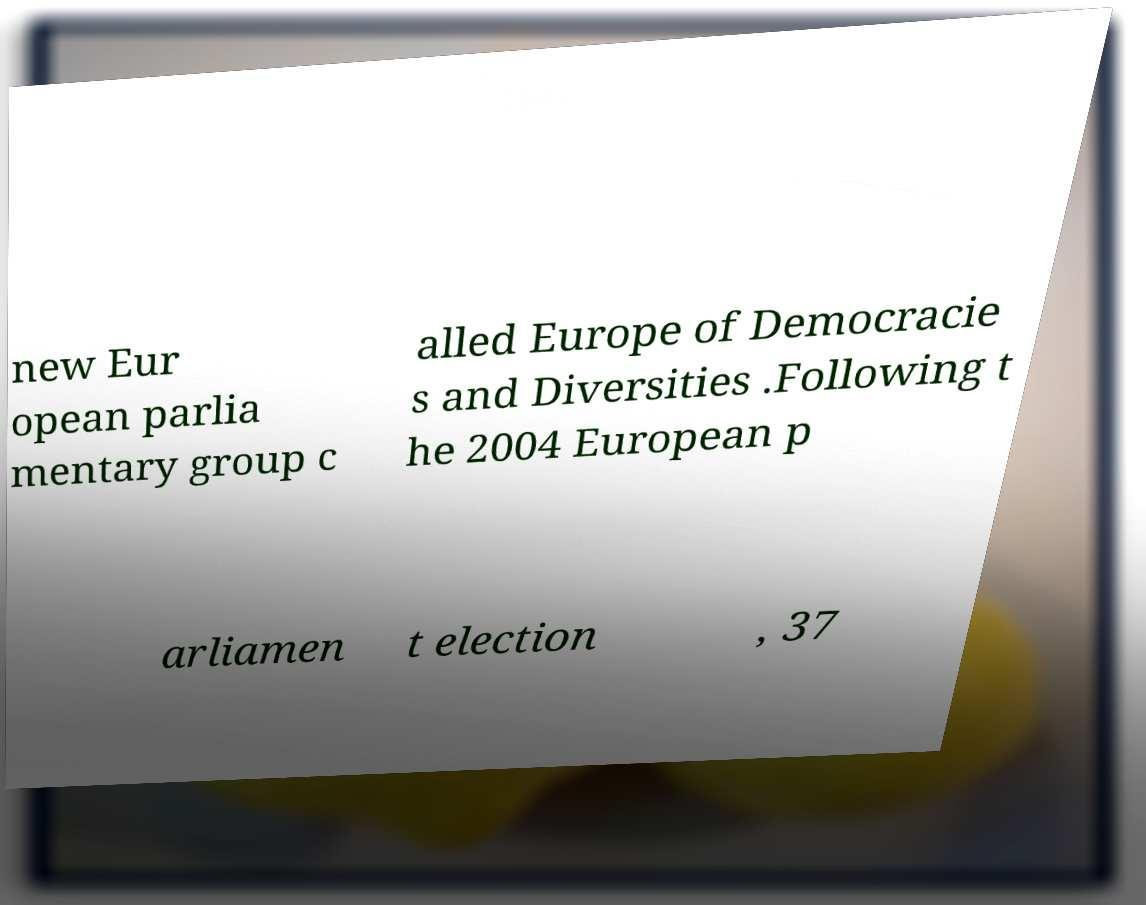Please read and relay the text visible in this image. What does it say? new Eur opean parlia mentary group c alled Europe of Democracie s and Diversities .Following t he 2004 European p arliamen t election , 37 